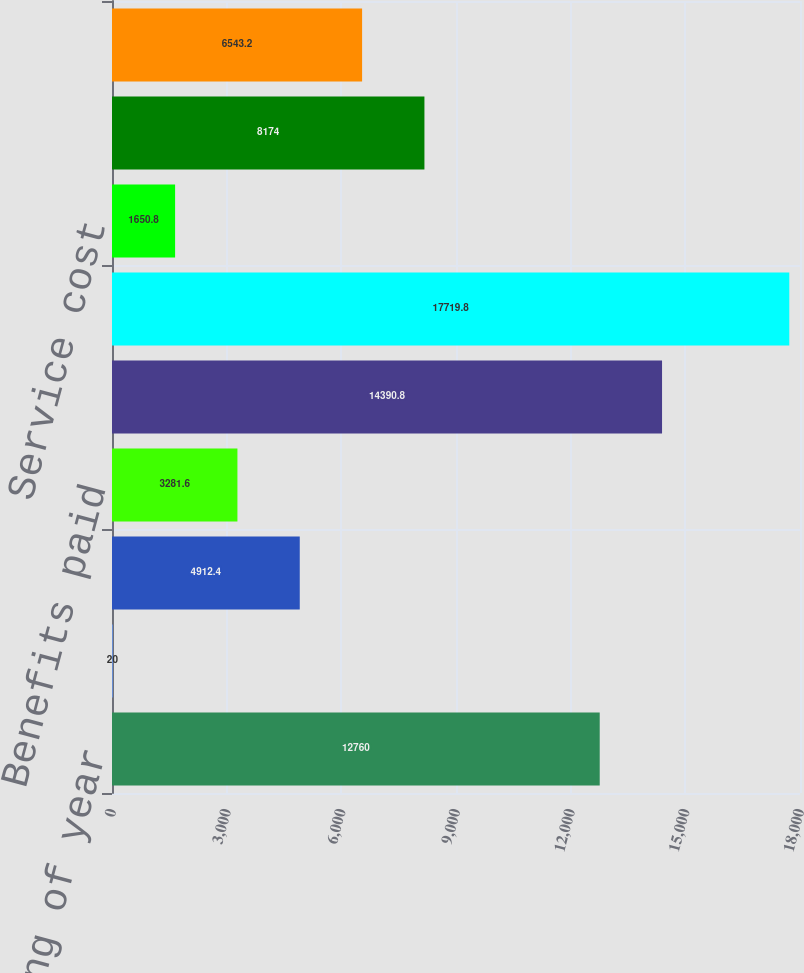Convert chart to OTSL. <chart><loc_0><loc_0><loc_500><loc_500><bar_chart><fcel>Fair value-beginning of year<fcel>Actual return on plan assets<fcel>Employer contributions<fcel>Benefits paid<fcel>Fair value-end of year<fcel>Projected benefit<fcel>Service cost<fcel>Interest cost<fcel>Actuarial loss (gain)<nl><fcel>12760<fcel>20<fcel>4912.4<fcel>3281.6<fcel>14390.8<fcel>17719.8<fcel>1650.8<fcel>8174<fcel>6543.2<nl></chart> 